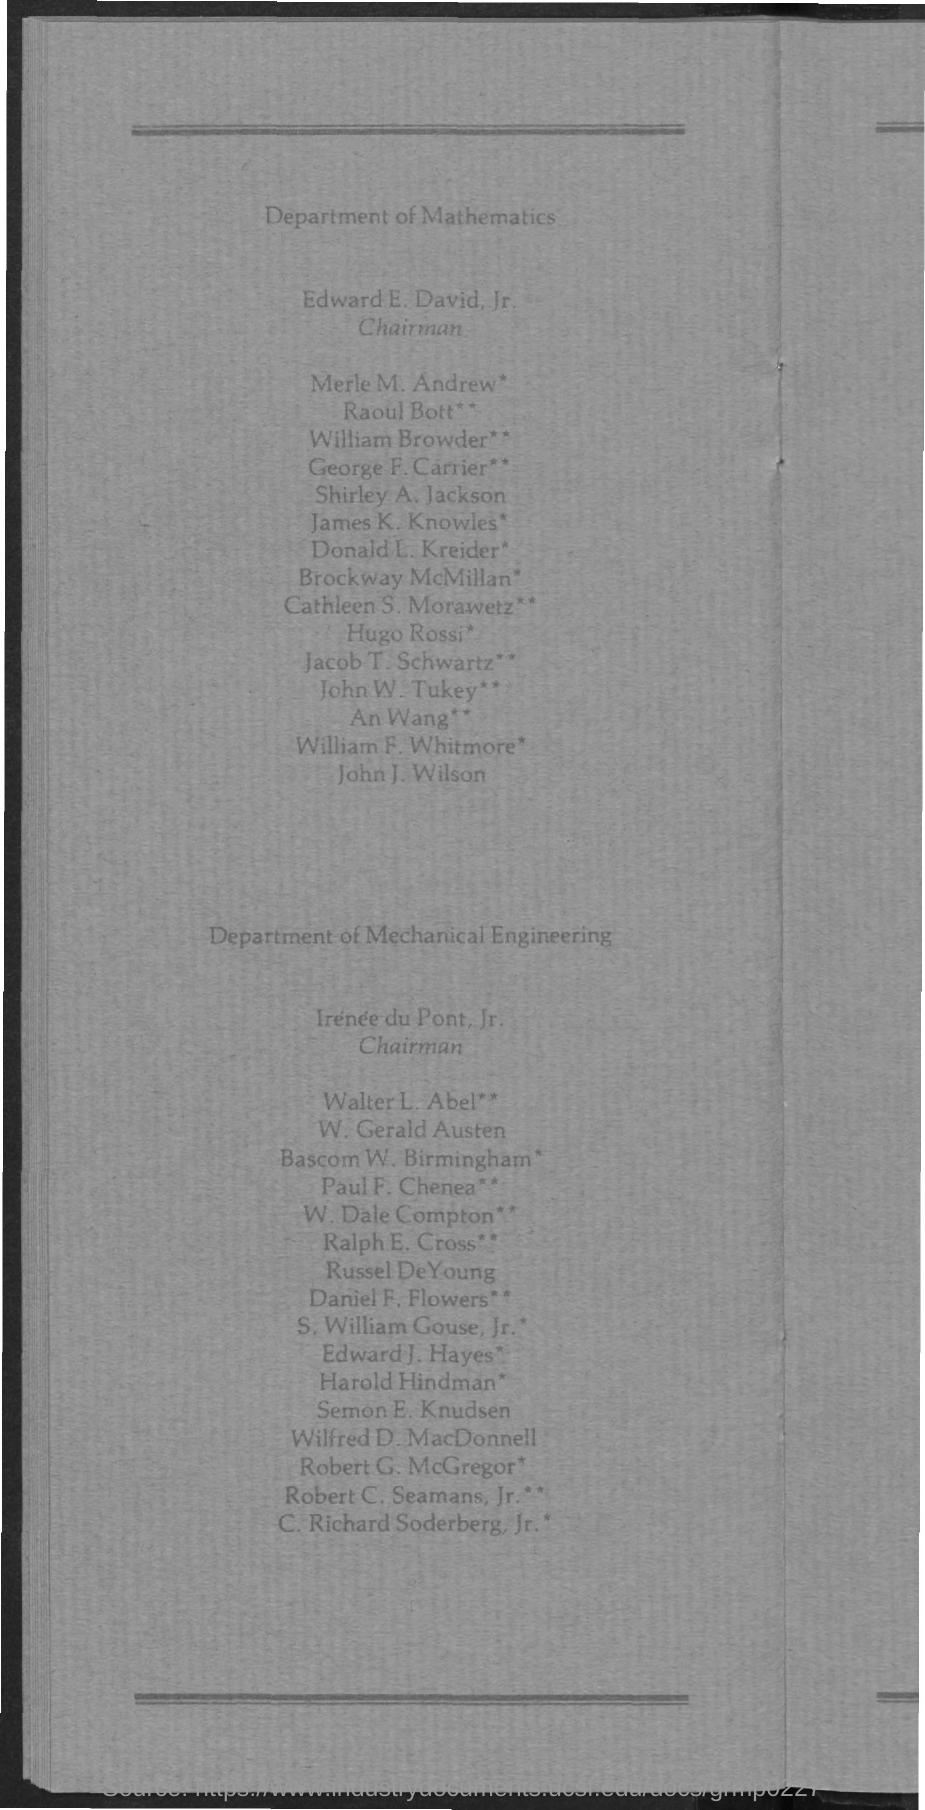Indicate a few pertinent items in this graphic. The Chairman of the Department of Mathematics is Edward E. David, Jr. 